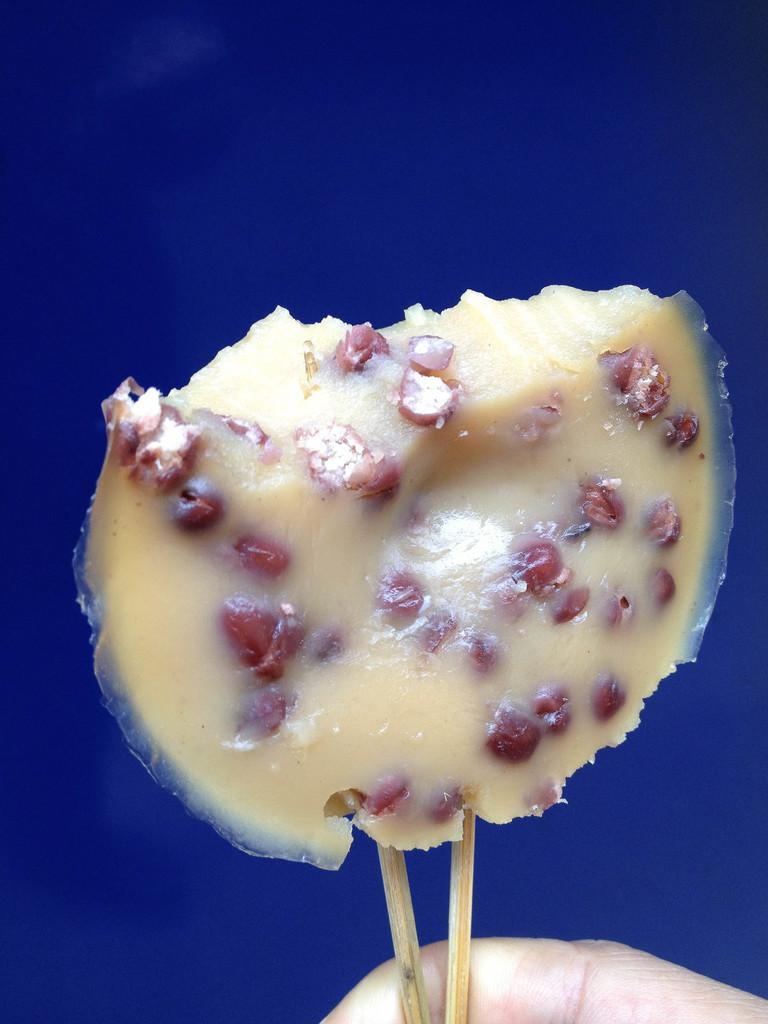What type of food can be seen in the image? There is a food item with sticks in the image. Can you describe any other elements in the image? A person's finger is visible at the bottom of the image. What color is the background of the image? The background of the image is blue. What type of calculator can be seen in the image? There is no calculator present in the image. Can you describe the mist in the image? There is no mist present in the image. 